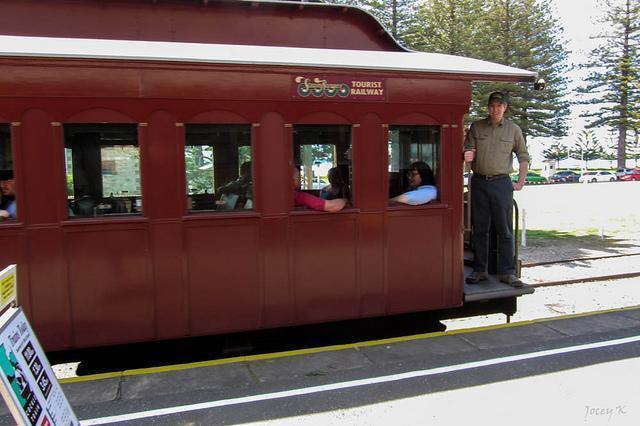What type passengers board this train?
Indicate the correct response and explain using: 'Answer: answer
Rationale: rationale.'
Options: Commuters, none, tourists, engineers only. Answer: tourists.
Rationale: The type is a tourist. 